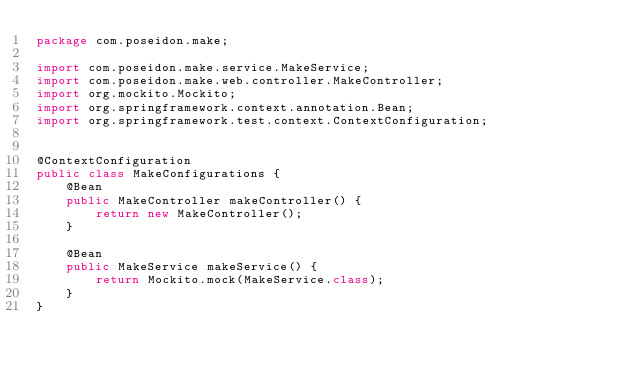Convert code to text. <code><loc_0><loc_0><loc_500><loc_500><_Java_>package com.poseidon.make;

import com.poseidon.make.service.MakeService;
import com.poseidon.make.web.controller.MakeController;
import org.mockito.Mockito;
import org.springframework.context.annotation.Bean;
import org.springframework.test.context.ContextConfiguration;


@ContextConfiguration
public class MakeConfigurations {
    @Bean
    public MakeController makeController() {
        return new MakeController();
    }

    @Bean
    public MakeService makeService() {
        return Mockito.mock(MakeService.class);
    }
}
</code> 